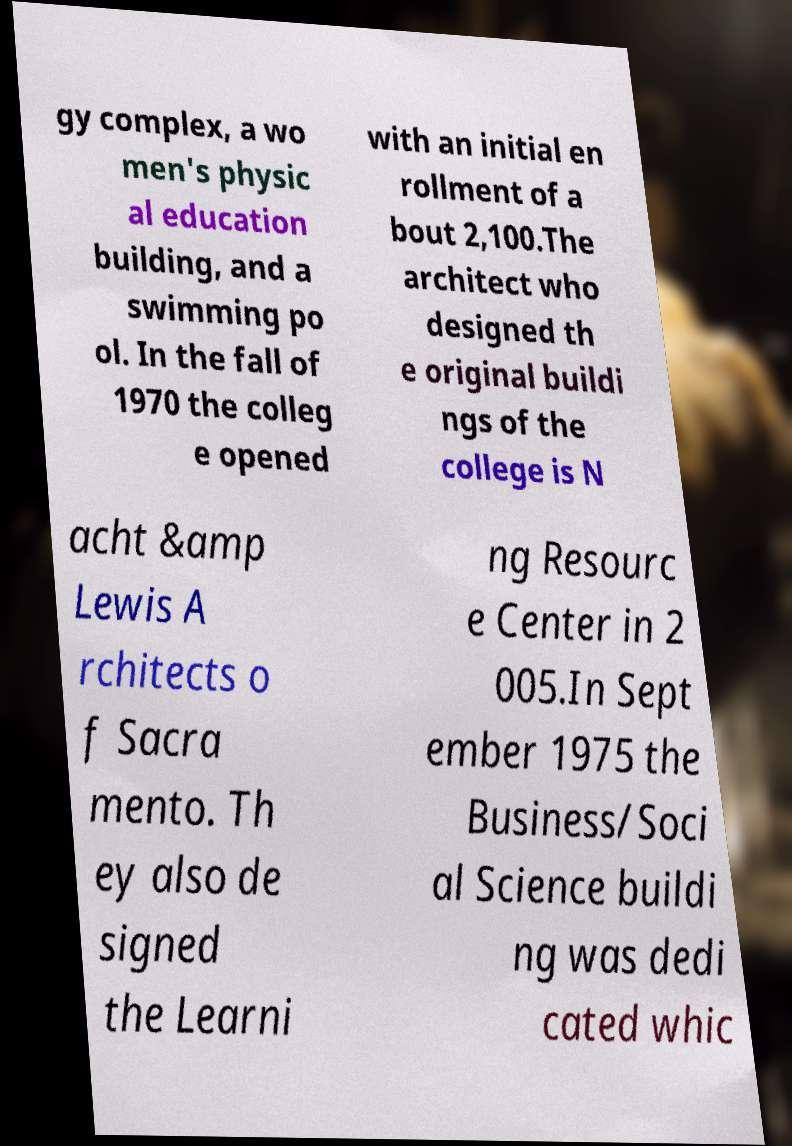Please identify and transcribe the text found in this image. gy complex, a wo men's physic al education building, and a swimming po ol. In the fall of 1970 the colleg e opened with an initial en rollment of a bout 2,100.The architect who designed th e original buildi ngs of the college is N acht &amp Lewis A rchitects o f Sacra mento. Th ey also de signed the Learni ng Resourc e Center in 2 005.In Sept ember 1975 the Business/Soci al Science buildi ng was dedi cated whic 